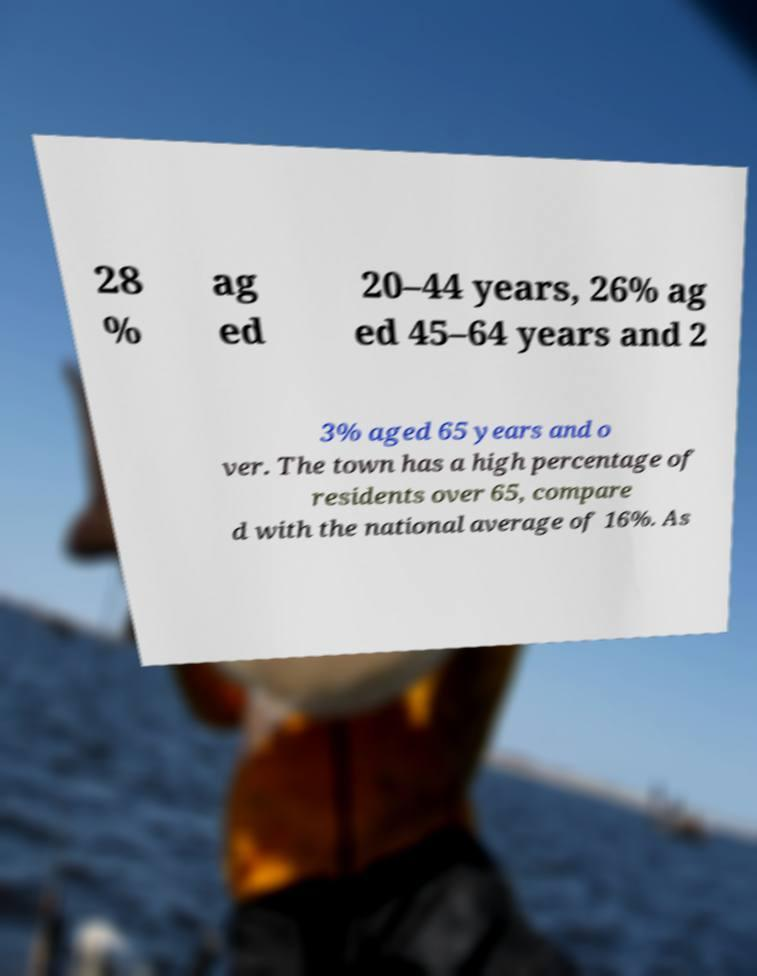Please read and relay the text visible in this image. What does it say? 28 % ag ed 20–44 years, 26% ag ed 45–64 years and 2 3% aged 65 years and o ver. The town has a high percentage of residents over 65, compare d with the national average of 16%. As 